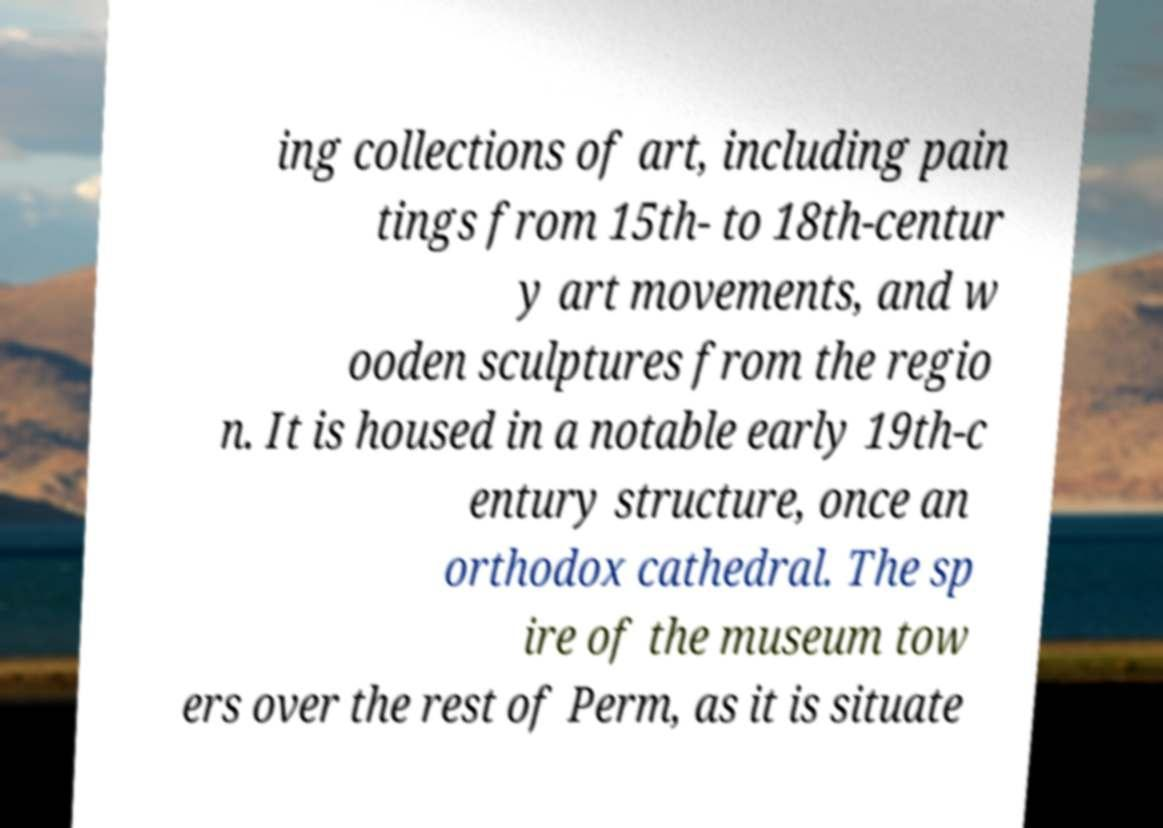Can you read and provide the text displayed in the image?This photo seems to have some interesting text. Can you extract and type it out for me? ing collections of art, including pain tings from 15th- to 18th-centur y art movements, and w ooden sculptures from the regio n. It is housed in a notable early 19th-c entury structure, once an orthodox cathedral. The sp ire of the museum tow ers over the rest of Perm, as it is situate 